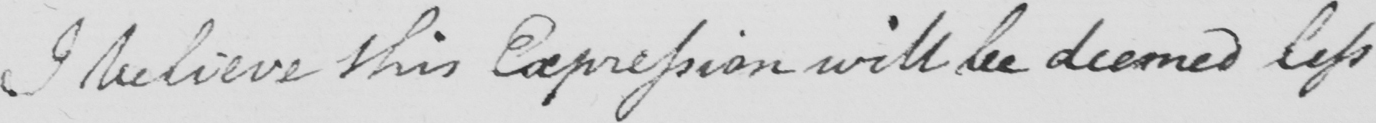Can you read and transcribe this handwriting? I believe this Expression will be deemed less 